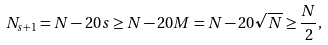<formula> <loc_0><loc_0><loc_500><loc_500>N _ { s + 1 } = N - 2 0 s \geq N - 2 0 M = N - 2 0 \sqrt { N } \geq \frac { N } 2 ,</formula> 